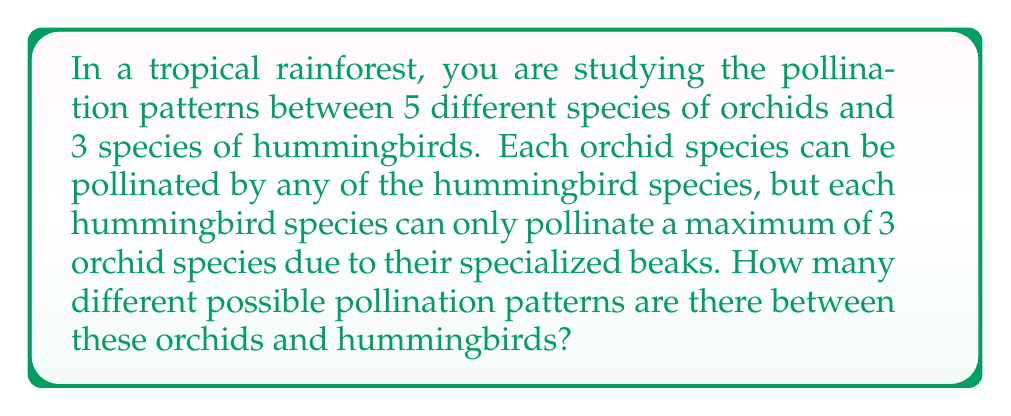Could you help me with this problem? Let's approach this step-by-step:

1) First, we need to consider each hummingbird species individually. For each hummingbird, we need to choose which orchids it will pollinate (up to 3).

2) This is a combination problem. For each hummingbird, we're choosing anywhere from 0 to 3 orchids out of 5.

3) The number of ways to choose $k$ items from $n$ items is given by the combination formula:

   $$\binom{n}{k} = \frac{n!}{k!(n-k)!}$$

4) For each hummingbird, the total number of possibilities is:

   $$\binom{5}{0} + \binom{5}{1} + \binom{5}{2} + \binom{5}{3}$$

5) Let's calculate each term:
   $$\binom{5}{0} = 1$$
   $$\binom{5}{1} = 5$$
   $$\binom{5}{2} = 10$$
   $$\binom{5}{3} = 10$$

6) Sum these up: $1 + 5 + 10 + 10 = 26$

7) This means each hummingbird has 26 possible pollination patterns.

8) Since there are 3 hummingbird species, and each can choose independently, we multiply these possibilities:

   $$26 \times 26 \times 26 = 26^3 = 17,576$$

Therefore, there are 17,576 different possible pollination patterns.
Answer: 17,576 